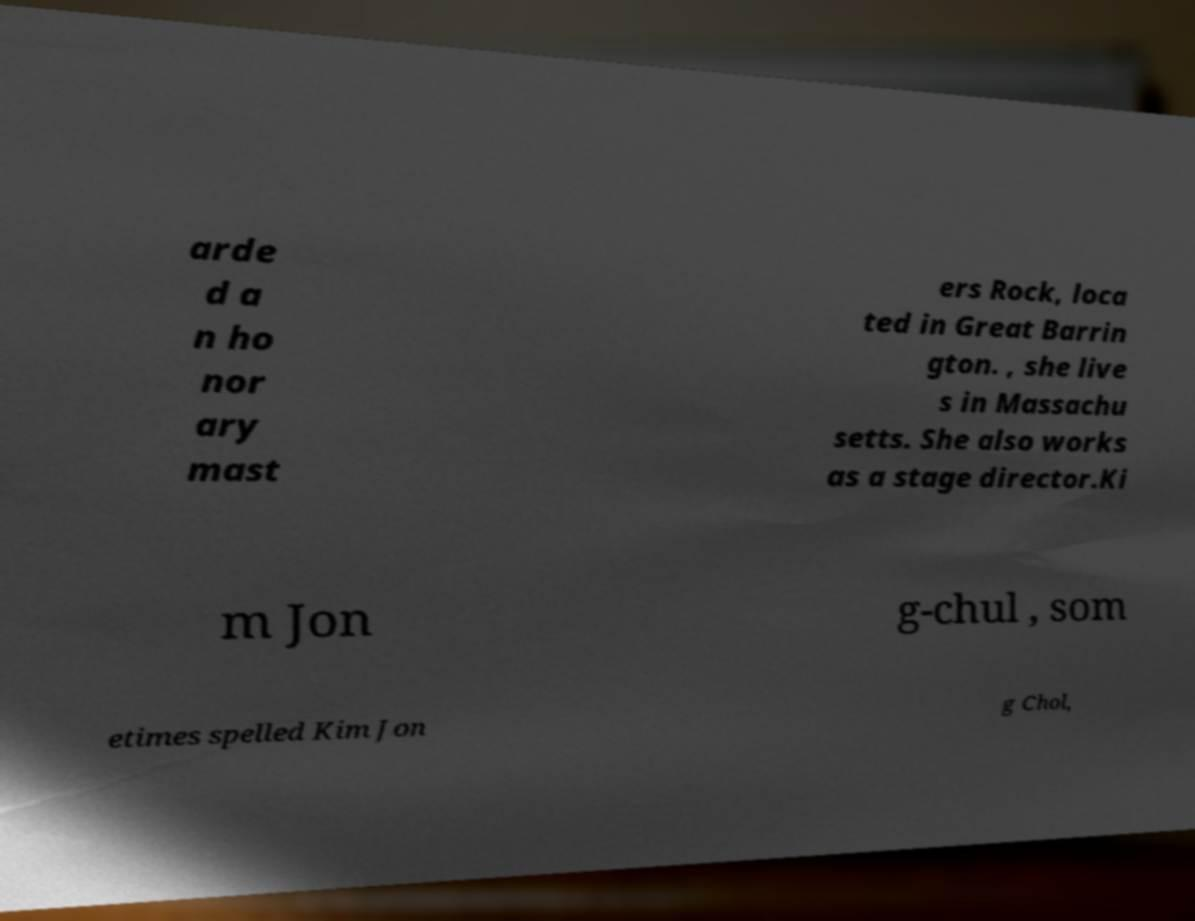For documentation purposes, I need the text within this image transcribed. Could you provide that? arde d a n ho nor ary mast ers Rock, loca ted in Great Barrin gton. , she live s in Massachu setts. She also works as a stage director.Ki m Jon g-chul , som etimes spelled Kim Jon g Chol, 